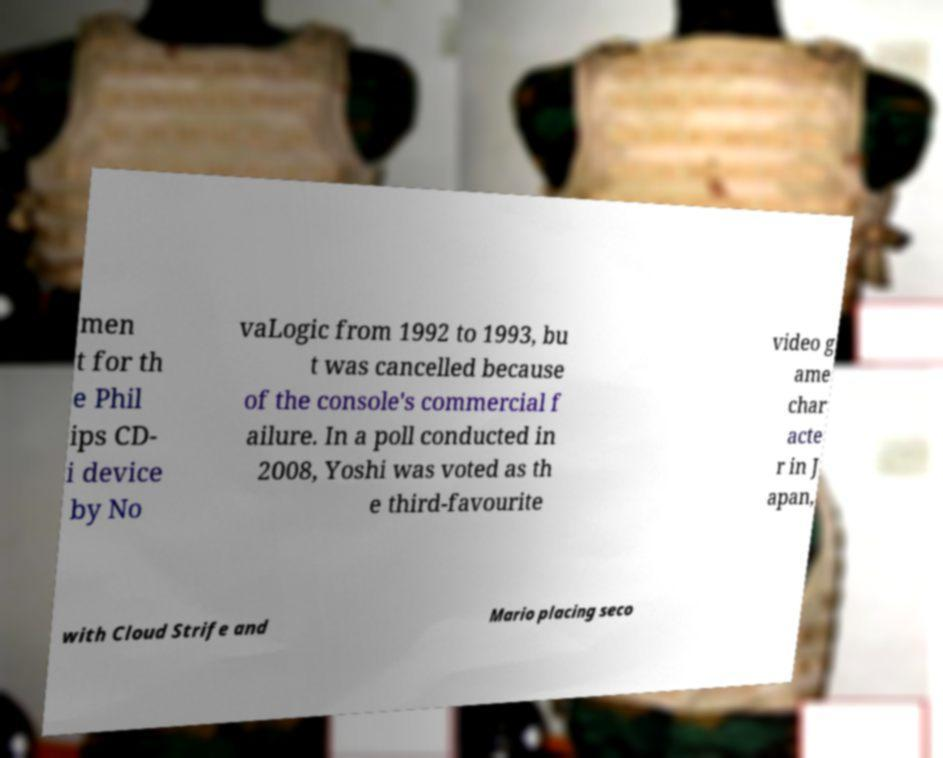Can you accurately transcribe the text from the provided image for me? men t for th e Phil ips CD- i device by No vaLogic from 1992 to 1993, bu t was cancelled because of the console's commercial f ailure. In a poll conducted in 2008, Yoshi was voted as th e third-favourite video g ame char acte r in J apan, with Cloud Strife and Mario placing seco 